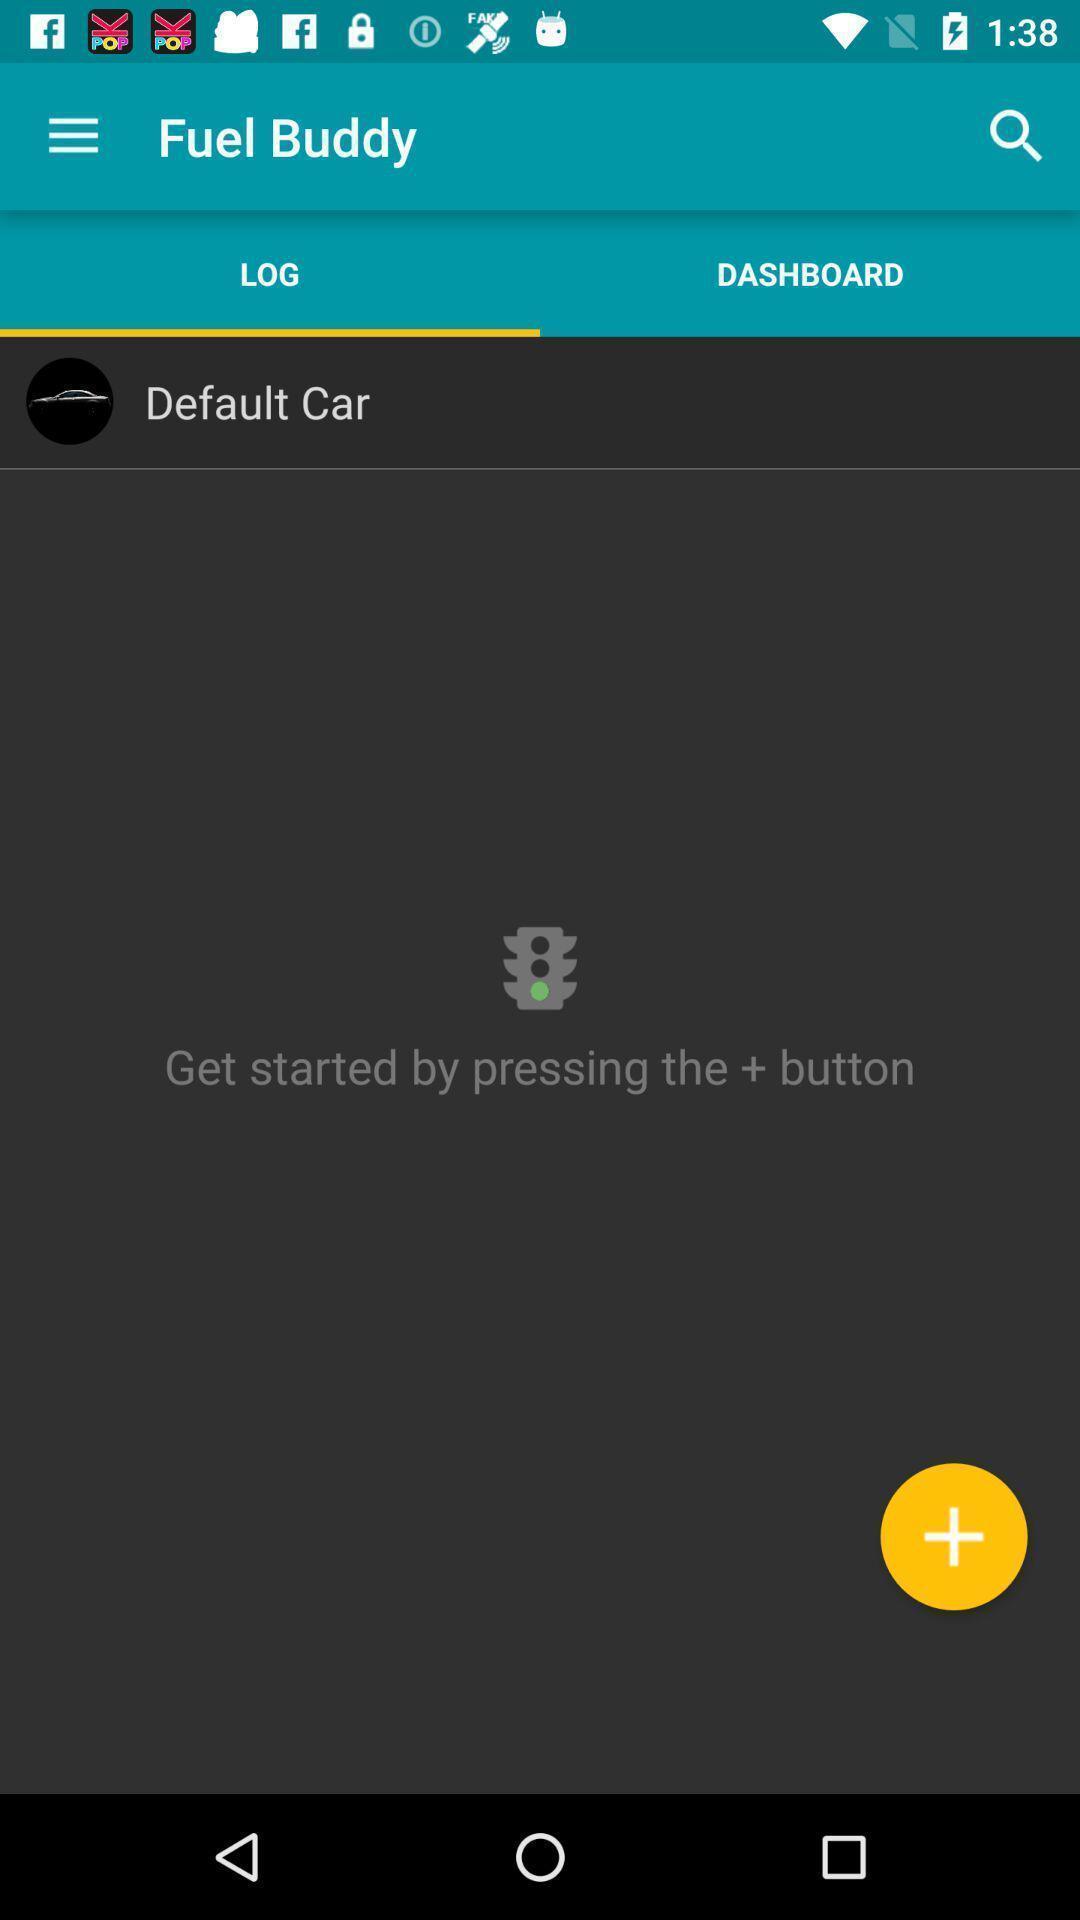Give me a summary of this screen capture. Window displaying the car app. 